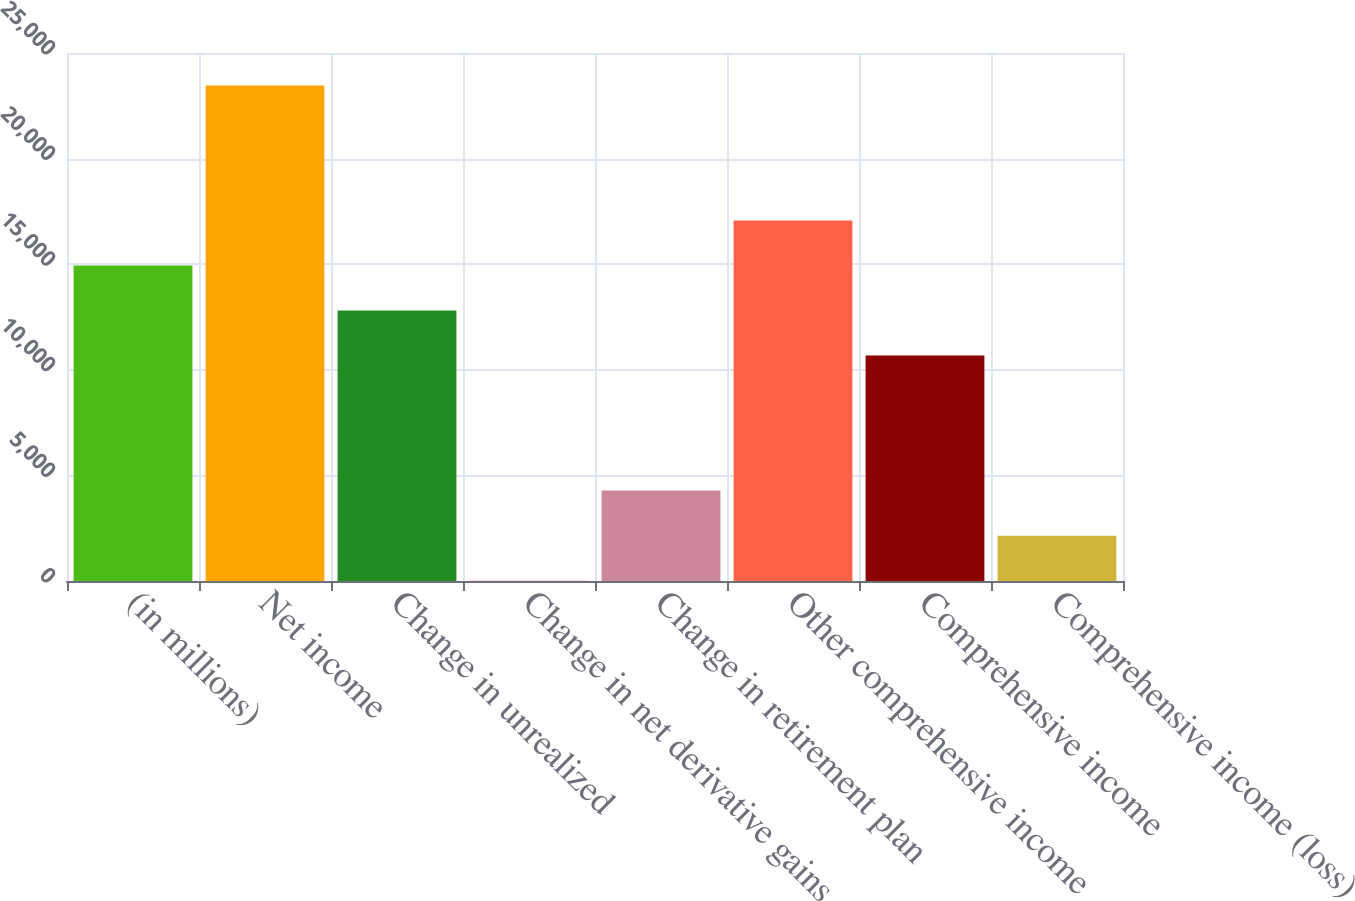Convert chart to OTSL. <chart><loc_0><loc_0><loc_500><loc_500><bar_chart><fcel>(in millions)<fcel>Net income<fcel>Change in unrealized<fcel>Change in net derivative gains<fcel>Change in retirement plan<fcel>Other comprehensive income<fcel>Comprehensive income<fcel>Comprehensive income (loss)<nl><fcel>14936.1<fcel>23461.3<fcel>12804.8<fcel>17<fcel>4279.6<fcel>17067.4<fcel>10673.5<fcel>2148.3<nl></chart> 